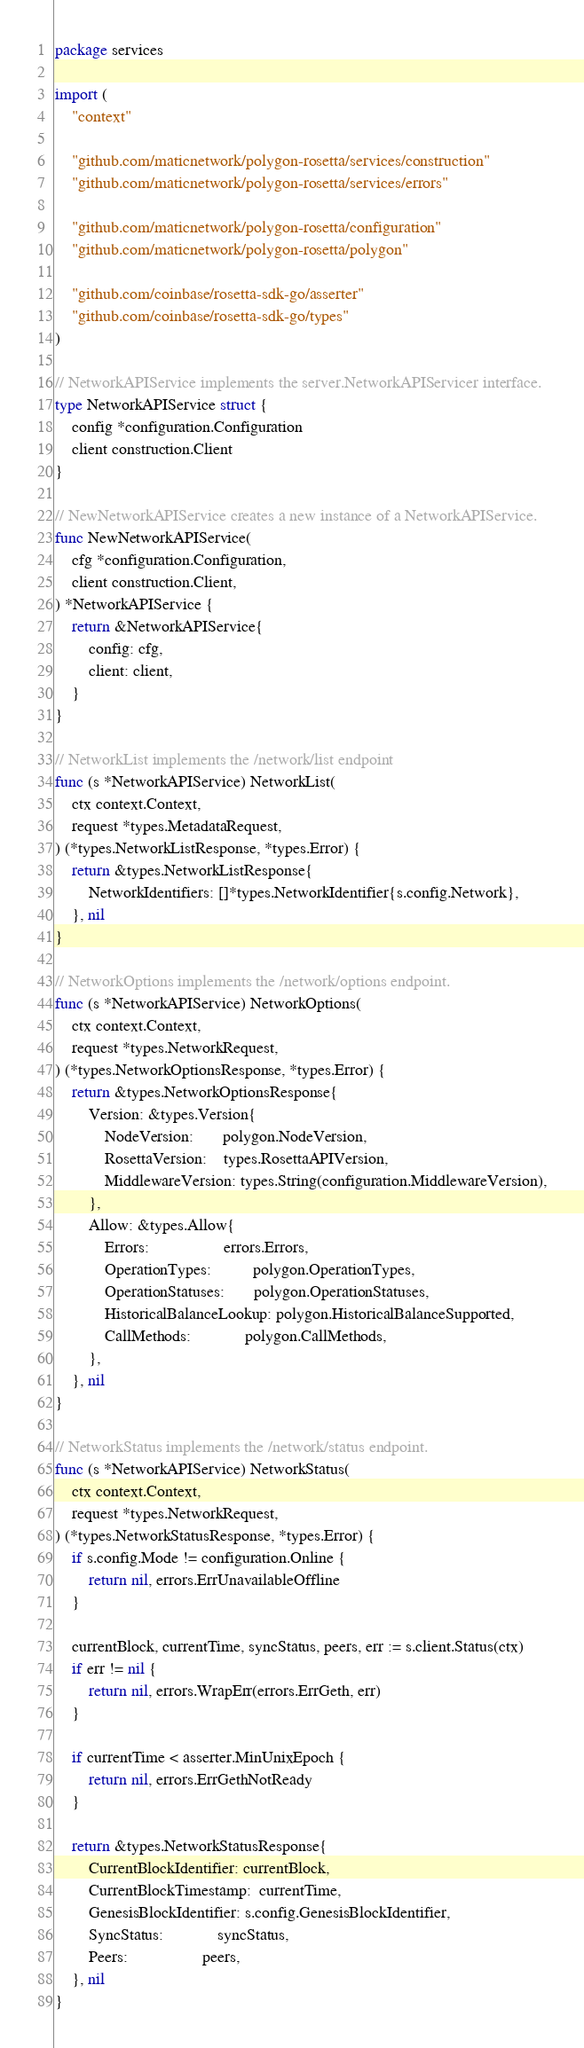<code> <loc_0><loc_0><loc_500><loc_500><_Go_>package services

import (
	"context"

	"github.com/maticnetwork/polygon-rosetta/services/construction"
	"github.com/maticnetwork/polygon-rosetta/services/errors"

	"github.com/maticnetwork/polygon-rosetta/configuration"
	"github.com/maticnetwork/polygon-rosetta/polygon"

	"github.com/coinbase/rosetta-sdk-go/asserter"
	"github.com/coinbase/rosetta-sdk-go/types"
)

// NetworkAPIService implements the server.NetworkAPIServicer interface.
type NetworkAPIService struct {
	config *configuration.Configuration
	client construction.Client
}

// NewNetworkAPIService creates a new instance of a NetworkAPIService.
func NewNetworkAPIService(
	cfg *configuration.Configuration,
	client construction.Client,
) *NetworkAPIService {
	return &NetworkAPIService{
		config: cfg,
		client: client,
	}
}

// NetworkList implements the /network/list endpoint
func (s *NetworkAPIService) NetworkList(
	ctx context.Context,
	request *types.MetadataRequest,
) (*types.NetworkListResponse, *types.Error) {
	return &types.NetworkListResponse{
		NetworkIdentifiers: []*types.NetworkIdentifier{s.config.Network},
	}, nil
}

// NetworkOptions implements the /network/options endpoint.
func (s *NetworkAPIService) NetworkOptions(
	ctx context.Context,
	request *types.NetworkRequest,
) (*types.NetworkOptionsResponse, *types.Error) {
	return &types.NetworkOptionsResponse{
		Version: &types.Version{
			NodeVersion:       polygon.NodeVersion,
			RosettaVersion:    types.RosettaAPIVersion,
			MiddlewareVersion: types.String(configuration.MiddlewareVersion),
		},
		Allow: &types.Allow{
			Errors:                  errors.Errors,
			OperationTypes:          polygon.OperationTypes,
			OperationStatuses:       polygon.OperationStatuses,
			HistoricalBalanceLookup: polygon.HistoricalBalanceSupported,
			CallMethods:             polygon.CallMethods,
		},
	}, nil
}

// NetworkStatus implements the /network/status endpoint.
func (s *NetworkAPIService) NetworkStatus(
	ctx context.Context,
	request *types.NetworkRequest,
) (*types.NetworkStatusResponse, *types.Error) {
	if s.config.Mode != configuration.Online {
		return nil, errors.ErrUnavailableOffline
	}

	currentBlock, currentTime, syncStatus, peers, err := s.client.Status(ctx)
	if err != nil {
		return nil, errors.WrapErr(errors.ErrGeth, err)
	}

	if currentTime < asserter.MinUnixEpoch {
		return nil, errors.ErrGethNotReady
	}

	return &types.NetworkStatusResponse{
		CurrentBlockIdentifier: currentBlock,
		CurrentBlockTimestamp:  currentTime,
		GenesisBlockIdentifier: s.config.GenesisBlockIdentifier,
		SyncStatus:             syncStatus,
		Peers:                  peers,
	}, nil
}
</code> 